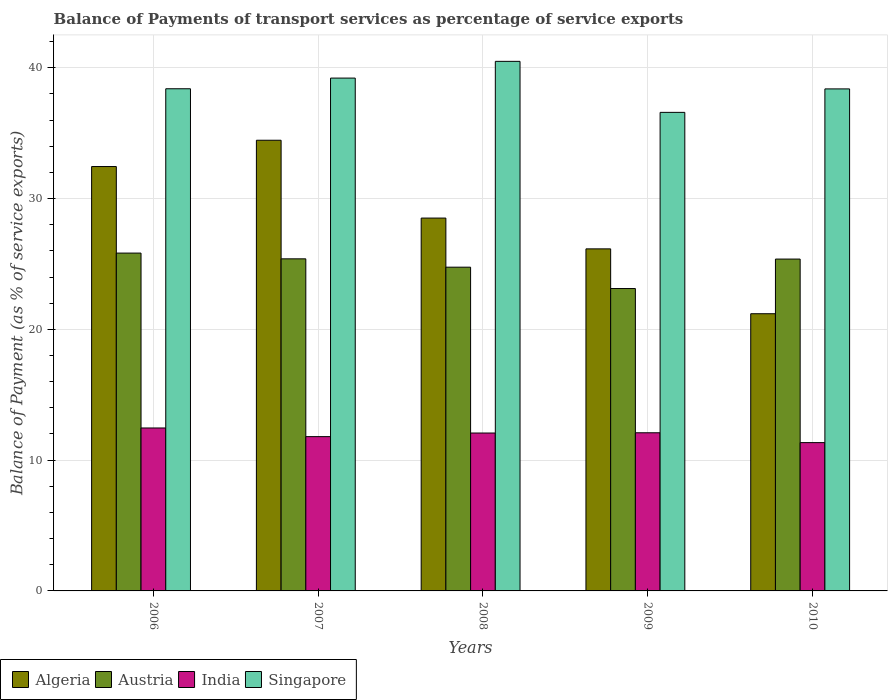How many different coloured bars are there?
Keep it short and to the point. 4. Are the number of bars per tick equal to the number of legend labels?
Your response must be concise. Yes. Are the number of bars on each tick of the X-axis equal?
Your answer should be very brief. Yes. How many bars are there on the 1st tick from the left?
Give a very brief answer. 4. How many bars are there on the 3rd tick from the right?
Give a very brief answer. 4. What is the label of the 1st group of bars from the left?
Keep it short and to the point. 2006. In how many cases, is the number of bars for a given year not equal to the number of legend labels?
Keep it short and to the point. 0. What is the balance of payments of transport services in Singapore in 2007?
Keep it short and to the point. 39.21. Across all years, what is the maximum balance of payments of transport services in Singapore?
Provide a short and direct response. 40.49. Across all years, what is the minimum balance of payments of transport services in Singapore?
Offer a very short reply. 36.59. In which year was the balance of payments of transport services in Singapore minimum?
Your answer should be compact. 2009. What is the total balance of payments of transport services in Austria in the graph?
Offer a very short reply. 124.48. What is the difference between the balance of payments of transport services in Algeria in 2009 and that in 2010?
Give a very brief answer. 4.96. What is the difference between the balance of payments of transport services in Austria in 2007 and the balance of payments of transport services in Algeria in 2006?
Offer a very short reply. -7.06. What is the average balance of payments of transport services in Singapore per year?
Provide a short and direct response. 38.62. In the year 2010, what is the difference between the balance of payments of transport services in Singapore and balance of payments of transport services in India?
Offer a terse response. 27.05. What is the ratio of the balance of payments of transport services in Algeria in 2006 to that in 2008?
Your response must be concise. 1.14. Is the balance of payments of transport services in India in 2006 less than that in 2008?
Ensure brevity in your answer.  No. What is the difference between the highest and the second highest balance of payments of transport services in Austria?
Your response must be concise. 0.44. What is the difference between the highest and the lowest balance of payments of transport services in India?
Keep it short and to the point. 1.12. Is it the case that in every year, the sum of the balance of payments of transport services in Austria and balance of payments of transport services in Singapore is greater than the balance of payments of transport services in India?
Offer a very short reply. Yes. How many bars are there?
Make the answer very short. 20. How many years are there in the graph?
Keep it short and to the point. 5. Are the values on the major ticks of Y-axis written in scientific E-notation?
Make the answer very short. No. Where does the legend appear in the graph?
Your answer should be very brief. Bottom left. How many legend labels are there?
Ensure brevity in your answer.  4. How are the legend labels stacked?
Keep it short and to the point. Horizontal. What is the title of the graph?
Provide a succinct answer. Balance of Payments of transport services as percentage of service exports. Does "Tuvalu" appear as one of the legend labels in the graph?
Provide a succinct answer. No. What is the label or title of the Y-axis?
Your answer should be compact. Balance of Payment (as % of service exports). What is the Balance of Payment (as % of service exports) in Algeria in 2006?
Your response must be concise. 32.45. What is the Balance of Payment (as % of service exports) of Austria in 2006?
Ensure brevity in your answer.  25.83. What is the Balance of Payment (as % of service exports) of India in 2006?
Your answer should be very brief. 12.46. What is the Balance of Payment (as % of service exports) in Singapore in 2006?
Ensure brevity in your answer.  38.4. What is the Balance of Payment (as % of service exports) in Algeria in 2007?
Your response must be concise. 34.46. What is the Balance of Payment (as % of service exports) of Austria in 2007?
Provide a succinct answer. 25.39. What is the Balance of Payment (as % of service exports) of India in 2007?
Your response must be concise. 11.8. What is the Balance of Payment (as % of service exports) in Singapore in 2007?
Provide a short and direct response. 39.21. What is the Balance of Payment (as % of service exports) of Algeria in 2008?
Your response must be concise. 28.51. What is the Balance of Payment (as % of service exports) of Austria in 2008?
Your answer should be very brief. 24.75. What is the Balance of Payment (as % of service exports) in India in 2008?
Your response must be concise. 12.07. What is the Balance of Payment (as % of service exports) in Singapore in 2008?
Offer a very short reply. 40.49. What is the Balance of Payment (as % of service exports) in Algeria in 2009?
Keep it short and to the point. 26.15. What is the Balance of Payment (as % of service exports) of Austria in 2009?
Keep it short and to the point. 23.12. What is the Balance of Payment (as % of service exports) in India in 2009?
Keep it short and to the point. 12.09. What is the Balance of Payment (as % of service exports) of Singapore in 2009?
Make the answer very short. 36.59. What is the Balance of Payment (as % of service exports) of Algeria in 2010?
Provide a short and direct response. 21.2. What is the Balance of Payment (as % of service exports) in Austria in 2010?
Make the answer very short. 25.37. What is the Balance of Payment (as % of service exports) in India in 2010?
Give a very brief answer. 11.34. What is the Balance of Payment (as % of service exports) of Singapore in 2010?
Provide a succinct answer. 38.39. Across all years, what is the maximum Balance of Payment (as % of service exports) of Algeria?
Your response must be concise. 34.46. Across all years, what is the maximum Balance of Payment (as % of service exports) of Austria?
Provide a succinct answer. 25.83. Across all years, what is the maximum Balance of Payment (as % of service exports) of India?
Provide a short and direct response. 12.46. Across all years, what is the maximum Balance of Payment (as % of service exports) of Singapore?
Keep it short and to the point. 40.49. Across all years, what is the minimum Balance of Payment (as % of service exports) in Algeria?
Offer a very short reply. 21.2. Across all years, what is the minimum Balance of Payment (as % of service exports) of Austria?
Provide a succinct answer. 23.12. Across all years, what is the minimum Balance of Payment (as % of service exports) of India?
Make the answer very short. 11.34. Across all years, what is the minimum Balance of Payment (as % of service exports) of Singapore?
Provide a succinct answer. 36.59. What is the total Balance of Payment (as % of service exports) of Algeria in the graph?
Your response must be concise. 142.77. What is the total Balance of Payment (as % of service exports) in Austria in the graph?
Offer a terse response. 124.48. What is the total Balance of Payment (as % of service exports) in India in the graph?
Your answer should be very brief. 59.76. What is the total Balance of Payment (as % of service exports) of Singapore in the graph?
Keep it short and to the point. 193.08. What is the difference between the Balance of Payment (as % of service exports) of Algeria in 2006 and that in 2007?
Give a very brief answer. -2.01. What is the difference between the Balance of Payment (as % of service exports) in Austria in 2006 and that in 2007?
Make the answer very short. 0.44. What is the difference between the Balance of Payment (as % of service exports) in India in 2006 and that in 2007?
Provide a succinct answer. 0.66. What is the difference between the Balance of Payment (as % of service exports) in Singapore in 2006 and that in 2007?
Provide a succinct answer. -0.82. What is the difference between the Balance of Payment (as % of service exports) in Algeria in 2006 and that in 2008?
Make the answer very short. 3.94. What is the difference between the Balance of Payment (as % of service exports) in Austria in 2006 and that in 2008?
Offer a very short reply. 1.08. What is the difference between the Balance of Payment (as % of service exports) in India in 2006 and that in 2008?
Offer a very short reply. 0.39. What is the difference between the Balance of Payment (as % of service exports) of Singapore in 2006 and that in 2008?
Offer a terse response. -2.1. What is the difference between the Balance of Payment (as % of service exports) in Algeria in 2006 and that in 2009?
Your response must be concise. 6.29. What is the difference between the Balance of Payment (as % of service exports) in Austria in 2006 and that in 2009?
Provide a short and direct response. 2.71. What is the difference between the Balance of Payment (as % of service exports) in India in 2006 and that in 2009?
Your response must be concise. 0.37. What is the difference between the Balance of Payment (as % of service exports) of Singapore in 2006 and that in 2009?
Your answer should be very brief. 1.81. What is the difference between the Balance of Payment (as % of service exports) of Algeria in 2006 and that in 2010?
Provide a succinct answer. 11.25. What is the difference between the Balance of Payment (as % of service exports) in Austria in 2006 and that in 2010?
Your answer should be compact. 0.46. What is the difference between the Balance of Payment (as % of service exports) in India in 2006 and that in 2010?
Make the answer very short. 1.12. What is the difference between the Balance of Payment (as % of service exports) in Singapore in 2006 and that in 2010?
Make the answer very short. 0.01. What is the difference between the Balance of Payment (as % of service exports) of Algeria in 2007 and that in 2008?
Offer a terse response. 5.95. What is the difference between the Balance of Payment (as % of service exports) in Austria in 2007 and that in 2008?
Give a very brief answer. 0.64. What is the difference between the Balance of Payment (as % of service exports) in India in 2007 and that in 2008?
Make the answer very short. -0.28. What is the difference between the Balance of Payment (as % of service exports) of Singapore in 2007 and that in 2008?
Give a very brief answer. -1.28. What is the difference between the Balance of Payment (as % of service exports) of Algeria in 2007 and that in 2009?
Provide a short and direct response. 8.31. What is the difference between the Balance of Payment (as % of service exports) of Austria in 2007 and that in 2009?
Your answer should be compact. 2.27. What is the difference between the Balance of Payment (as % of service exports) of India in 2007 and that in 2009?
Give a very brief answer. -0.3. What is the difference between the Balance of Payment (as % of service exports) of Singapore in 2007 and that in 2009?
Your response must be concise. 2.62. What is the difference between the Balance of Payment (as % of service exports) in Algeria in 2007 and that in 2010?
Keep it short and to the point. 13.27. What is the difference between the Balance of Payment (as % of service exports) in Austria in 2007 and that in 2010?
Keep it short and to the point. 0.02. What is the difference between the Balance of Payment (as % of service exports) of India in 2007 and that in 2010?
Your answer should be compact. 0.46. What is the difference between the Balance of Payment (as % of service exports) in Singapore in 2007 and that in 2010?
Your answer should be compact. 0.83. What is the difference between the Balance of Payment (as % of service exports) of Algeria in 2008 and that in 2009?
Offer a very short reply. 2.35. What is the difference between the Balance of Payment (as % of service exports) in Austria in 2008 and that in 2009?
Your answer should be very brief. 1.63. What is the difference between the Balance of Payment (as % of service exports) of India in 2008 and that in 2009?
Provide a short and direct response. -0.02. What is the difference between the Balance of Payment (as % of service exports) in Singapore in 2008 and that in 2009?
Make the answer very short. 3.9. What is the difference between the Balance of Payment (as % of service exports) of Algeria in 2008 and that in 2010?
Provide a short and direct response. 7.31. What is the difference between the Balance of Payment (as % of service exports) of Austria in 2008 and that in 2010?
Give a very brief answer. -0.62. What is the difference between the Balance of Payment (as % of service exports) in India in 2008 and that in 2010?
Your response must be concise. 0.73. What is the difference between the Balance of Payment (as % of service exports) in Singapore in 2008 and that in 2010?
Ensure brevity in your answer.  2.11. What is the difference between the Balance of Payment (as % of service exports) of Algeria in 2009 and that in 2010?
Make the answer very short. 4.96. What is the difference between the Balance of Payment (as % of service exports) in Austria in 2009 and that in 2010?
Your answer should be compact. -2.25. What is the difference between the Balance of Payment (as % of service exports) in India in 2009 and that in 2010?
Keep it short and to the point. 0.75. What is the difference between the Balance of Payment (as % of service exports) in Singapore in 2009 and that in 2010?
Provide a short and direct response. -1.79. What is the difference between the Balance of Payment (as % of service exports) of Algeria in 2006 and the Balance of Payment (as % of service exports) of Austria in 2007?
Ensure brevity in your answer.  7.06. What is the difference between the Balance of Payment (as % of service exports) in Algeria in 2006 and the Balance of Payment (as % of service exports) in India in 2007?
Keep it short and to the point. 20.65. What is the difference between the Balance of Payment (as % of service exports) in Algeria in 2006 and the Balance of Payment (as % of service exports) in Singapore in 2007?
Provide a succinct answer. -6.76. What is the difference between the Balance of Payment (as % of service exports) of Austria in 2006 and the Balance of Payment (as % of service exports) of India in 2007?
Make the answer very short. 14.03. What is the difference between the Balance of Payment (as % of service exports) in Austria in 2006 and the Balance of Payment (as % of service exports) in Singapore in 2007?
Give a very brief answer. -13.38. What is the difference between the Balance of Payment (as % of service exports) in India in 2006 and the Balance of Payment (as % of service exports) in Singapore in 2007?
Keep it short and to the point. -26.75. What is the difference between the Balance of Payment (as % of service exports) in Algeria in 2006 and the Balance of Payment (as % of service exports) in Austria in 2008?
Your answer should be compact. 7.69. What is the difference between the Balance of Payment (as % of service exports) in Algeria in 2006 and the Balance of Payment (as % of service exports) in India in 2008?
Your response must be concise. 20.38. What is the difference between the Balance of Payment (as % of service exports) in Algeria in 2006 and the Balance of Payment (as % of service exports) in Singapore in 2008?
Provide a short and direct response. -8.04. What is the difference between the Balance of Payment (as % of service exports) in Austria in 2006 and the Balance of Payment (as % of service exports) in India in 2008?
Provide a short and direct response. 13.76. What is the difference between the Balance of Payment (as % of service exports) in Austria in 2006 and the Balance of Payment (as % of service exports) in Singapore in 2008?
Your answer should be very brief. -14.66. What is the difference between the Balance of Payment (as % of service exports) of India in 2006 and the Balance of Payment (as % of service exports) of Singapore in 2008?
Give a very brief answer. -28.03. What is the difference between the Balance of Payment (as % of service exports) in Algeria in 2006 and the Balance of Payment (as % of service exports) in Austria in 2009?
Offer a terse response. 9.33. What is the difference between the Balance of Payment (as % of service exports) of Algeria in 2006 and the Balance of Payment (as % of service exports) of India in 2009?
Provide a short and direct response. 20.36. What is the difference between the Balance of Payment (as % of service exports) in Algeria in 2006 and the Balance of Payment (as % of service exports) in Singapore in 2009?
Your answer should be compact. -4.14. What is the difference between the Balance of Payment (as % of service exports) in Austria in 2006 and the Balance of Payment (as % of service exports) in India in 2009?
Offer a very short reply. 13.74. What is the difference between the Balance of Payment (as % of service exports) in Austria in 2006 and the Balance of Payment (as % of service exports) in Singapore in 2009?
Your answer should be very brief. -10.76. What is the difference between the Balance of Payment (as % of service exports) in India in 2006 and the Balance of Payment (as % of service exports) in Singapore in 2009?
Ensure brevity in your answer.  -24.13. What is the difference between the Balance of Payment (as % of service exports) in Algeria in 2006 and the Balance of Payment (as % of service exports) in Austria in 2010?
Ensure brevity in your answer.  7.07. What is the difference between the Balance of Payment (as % of service exports) in Algeria in 2006 and the Balance of Payment (as % of service exports) in India in 2010?
Make the answer very short. 21.11. What is the difference between the Balance of Payment (as % of service exports) of Algeria in 2006 and the Balance of Payment (as % of service exports) of Singapore in 2010?
Give a very brief answer. -5.94. What is the difference between the Balance of Payment (as % of service exports) of Austria in 2006 and the Balance of Payment (as % of service exports) of India in 2010?
Your answer should be compact. 14.49. What is the difference between the Balance of Payment (as % of service exports) of Austria in 2006 and the Balance of Payment (as % of service exports) of Singapore in 2010?
Your answer should be compact. -12.55. What is the difference between the Balance of Payment (as % of service exports) of India in 2006 and the Balance of Payment (as % of service exports) of Singapore in 2010?
Provide a succinct answer. -25.93. What is the difference between the Balance of Payment (as % of service exports) of Algeria in 2007 and the Balance of Payment (as % of service exports) of Austria in 2008?
Make the answer very short. 9.71. What is the difference between the Balance of Payment (as % of service exports) of Algeria in 2007 and the Balance of Payment (as % of service exports) of India in 2008?
Offer a terse response. 22.39. What is the difference between the Balance of Payment (as % of service exports) in Algeria in 2007 and the Balance of Payment (as % of service exports) in Singapore in 2008?
Keep it short and to the point. -6.03. What is the difference between the Balance of Payment (as % of service exports) of Austria in 2007 and the Balance of Payment (as % of service exports) of India in 2008?
Offer a terse response. 13.32. What is the difference between the Balance of Payment (as % of service exports) of Austria in 2007 and the Balance of Payment (as % of service exports) of Singapore in 2008?
Give a very brief answer. -15.1. What is the difference between the Balance of Payment (as % of service exports) in India in 2007 and the Balance of Payment (as % of service exports) in Singapore in 2008?
Your response must be concise. -28.7. What is the difference between the Balance of Payment (as % of service exports) of Algeria in 2007 and the Balance of Payment (as % of service exports) of Austria in 2009?
Make the answer very short. 11.34. What is the difference between the Balance of Payment (as % of service exports) of Algeria in 2007 and the Balance of Payment (as % of service exports) of India in 2009?
Make the answer very short. 22.37. What is the difference between the Balance of Payment (as % of service exports) in Algeria in 2007 and the Balance of Payment (as % of service exports) in Singapore in 2009?
Provide a short and direct response. -2.13. What is the difference between the Balance of Payment (as % of service exports) of Austria in 2007 and the Balance of Payment (as % of service exports) of India in 2009?
Give a very brief answer. 13.3. What is the difference between the Balance of Payment (as % of service exports) of Austria in 2007 and the Balance of Payment (as % of service exports) of Singapore in 2009?
Offer a terse response. -11.2. What is the difference between the Balance of Payment (as % of service exports) in India in 2007 and the Balance of Payment (as % of service exports) in Singapore in 2009?
Provide a succinct answer. -24.79. What is the difference between the Balance of Payment (as % of service exports) in Algeria in 2007 and the Balance of Payment (as % of service exports) in Austria in 2010?
Offer a terse response. 9.09. What is the difference between the Balance of Payment (as % of service exports) in Algeria in 2007 and the Balance of Payment (as % of service exports) in India in 2010?
Ensure brevity in your answer.  23.12. What is the difference between the Balance of Payment (as % of service exports) in Algeria in 2007 and the Balance of Payment (as % of service exports) in Singapore in 2010?
Provide a short and direct response. -3.93. What is the difference between the Balance of Payment (as % of service exports) in Austria in 2007 and the Balance of Payment (as % of service exports) in India in 2010?
Your answer should be compact. 14.05. What is the difference between the Balance of Payment (as % of service exports) in Austria in 2007 and the Balance of Payment (as % of service exports) in Singapore in 2010?
Your answer should be very brief. -12.99. What is the difference between the Balance of Payment (as % of service exports) in India in 2007 and the Balance of Payment (as % of service exports) in Singapore in 2010?
Keep it short and to the point. -26.59. What is the difference between the Balance of Payment (as % of service exports) of Algeria in 2008 and the Balance of Payment (as % of service exports) of Austria in 2009?
Make the answer very short. 5.39. What is the difference between the Balance of Payment (as % of service exports) in Algeria in 2008 and the Balance of Payment (as % of service exports) in India in 2009?
Make the answer very short. 16.42. What is the difference between the Balance of Payment (as % of service exports) in Algeria in 2008 and the Balance of Payment (as % of service exports) in Singapore in 2009?
Provide a succinct answer. -8.08. What is the difference between the Balance of Payment (as % of service exports) in Austria in 2008 and the Balance of Payment (as % of service exports) in India in 2009?
Offer a terse response. 12.66. What is the difference between the Balance of Payment (as % of service exports) of Austria in 2008 and the Balance of Payment (as % of service exports) of Singapore in 2009?
Make the answer very short. -11.84. What is the difference between the Balance of Payment (as % of service exports) in India in 2008 and the Balance of Payment (as % of service exports) in Singapore in 2009?
Your answer should be very brief. -24.52. What is the difference between the Balance of Payment (as % of service exports) in Algeria in 2008 and the Balance of Payment (as % of service exports) in Austria in 2010?
Your answer should be very brief. 3.13. What is the difference between the Balance of Payment (as % of service exports) of Algeria in 2008 and the Balance of Payment (as % of service exports) of India in 2010?
Provide a short and direct response. 17.17. What is the difference between the Balance of Payment (as % of service exports) in Algeria in 2008 and the Balance of Payment (as % of service exports) in Singapore in 2010?
Provide a short and direct response. -9.88. What is the difference between the Balance of Payment (as % of service exports) in Austria in 2008 and the Balance of Payment (as % of service exports) in India in 2010?
Make the answer very short. 13.41. What is the difference between the Balance of Payment (as % of service exports) of Austria in 2008 and the Balance of Payment (as % of service exports) of Singapore in 2010?
Keep it short and to the point. -13.63. What is the difference between the Balance of Payment (as % of service exports) in India in 2008 and the Balance of Payment (as % of service exports) in Singapore in 2010?
Your response must be concise. -26.31. What is the difference between the Balance of Payment (as % of service exports) in Algeria in 2009 and the Balance of Payment (as % of service exports) in Austria in 2010?
Offer a very short reply. 0.78. What is the difference between the Balance of Payment (as % of service exports) of Algeria in 2009 and the Balance of Payment (as % of service exports) of India in 2010?
Offer a very short reply. 14.81. What is the difference between the Balance of Payment (as % of service exports) of Algeria in 2009 and the Balance of Payment (as % of service exports) of Singapore in 2010?
Ensure brevity in your answer.  -12.23. What is the difference between the Balance of Payment (as % of service exports) in Austria in 2009 and the Balance of Payment (as % of service exports) in India in 2010?
Keep it short and to the point. 11.78. What is the difference between the Balance of Payment (as % of service exports) of Austria in 2009 and the Balance of Payment (as % of service exports) of Singapore in 2010?
Give a very brief answer. -15.26. What is the difference between the Balance of Payment (as % of service exports) in India in 2009 and the Balance of Payment (as % of service exports) in Singapore in 2010?
Provide a succinct answer. -26.29. What is the average Balance of Payment (as % of service exports) in Algeria per year?
Your response must be concise. 28.55. What is the average Balance of Payment (as % of service exports) in Austria per year?
Give a very brief answer. 24.89. What is the average Balance of Payment (as % of service exports) in India per year?
Offer a very short reply. 11.95. What is the average Balance of Payment (as % of service exports) in Singapore per year?
Keep it short and to the point. 38.62. In the year 2006, what is the difference between the Balance of Payment (as % of service exports) in Algeria and Balance of Payment (as % of service exports) in Austria?
Your answer should be compact. 6.62. In the year 2006, what is the difference between the Balance of Payment (as % of service exports) of Algeria and Balance of Payment (as % of service exports) of India?
Your answer should be compact. 19.99. In the year 2006, what is the difference between the Balance of Payment (as % of service exports) in Algeria and Balance of Payment (as % of service exports) in Singapore?
Your answer should be compact. -5.95. In the year 2006, what is the difference between the Balance of Payment (as % of service exports) in Austria and Balance of Payment (as % of service exports) in India?
Your answer should be very brief. 13.37. In the year 2006, what is the difference between the Balance of Payment (as % of service exports) of Austria and Balance of Payment (as % of service exports) of Singapore?
Give a very brief answer. -12.57. In the year 2006, what is the difference between the Balance of Payment (as % of service exports) of India and Balance of Payment (as % of service exports) of Singapore?
Your answer should be compact. -25.94. In the year 2007, what is the difference between the Balance of Payment (as % of service exports) in Algeria and Balance of Payment (as % of service exports) in Austria?
Give a very brief answer. 9.07. In the year 2007, what is the difference between the Balance of Payment (as % of service exports) in Algeria and Balance of Payment (as % of service exports) in India?
Keep it short and to the point. 22.66. In the year 2007, what is the difference between the Balance of Payment (as % of service exports) of Algeria and Balance of Payment (as % of service exports) of Singapore?
Make the answer very short. -4.75. In the year 2007, what is the difference between the Balance of Payment (as % of service exports) in Austria and Balance of Payment (as % of service exports) in India?
Offer a very short reply. 13.6. In the year 2007, what is the difference between the Balance of Payment (as % of service exports) in Austria and Balance of Payment (as % of service exports) in Singapore?
Your answer should be very brief. -13.82. In the year 2007, what is the difference between the Balance of Payment (as % of service exports) in India and Balance of Payment (as % of service exports) in Singapore?
Your response must be concise. -27.42. In the year 2008, what is the difference between the Balance of Payment (as % of service exports) of Algeria and Balance of Payment (as % of service exports) of Austria?
Ensure brevity in your answer.  3.75. In the year 2008, what is the difference between the Balance of Payment (as % of service exports) of Algeria and Balance of Payment (as % of service exports) of India?
Your answer should be very brief. 16.44. In the year 2008, what is the difference between the Balance of Payment (as % of service exports) of Algeria and Balance of Payment (as % of service exports) of Singapore?
Offer a terse response. -11.98. In the year 2008, what is the difference between the Balance of Payment (as % of service exports) of Austria and Balance of Payment (as % of service exports) of India?
Offer a terse response. 12.68. In the year 2008, what is the difference between the Balance of Payment (as % of service exports) in Austria and Balance of Payment (as % of service exports) in Singapore?
Provide a short and direct response. -15.74. In the year 2008, what is the difference between the Balance of Payment (as % of service exports) of India and Balance of Payment (as % of service exports) of Singapore?
Keep it short and to the point. -28.42. In the year 2009, what is the difference between the Balance of Payment (as % of service exports) in Algeria and Balance of Payment (as % of service exports) in Austria?
Give a very brief answer. 3.03. In the year 2009, what is the difference between the Balance of Payment (as % of service exports) of Algeria and Balance of Payment (as % of service exports) of India?
Your response must be concise. 14.06. In the year 2009, what is the difference between the Balance of Payment (as % of service exports) of Algeria and Balance of Payment (as % of service exports) of Singapore?
Give a very brief answer. -10.44. In the year 2009, what is the difference between the Balance of Payment (as % of service exports) in Austria and Balance of Payment (as % of service exports) in India?
Ensure brevity in your answer.  11.03. In the year 2009, what is the difference between the Balance of Payment (as % of service exports) in Austria and Balance of Payment (as % of service exports) in Singapore?
Your answer should be very brief. -13.47. In the year 2009, what is the difference between the Balance of Payment (as % of service exports) of India and Balance of Payment (as % of service exports) of Singapore?
Provide a short and direct response. -24.5. In the year 2010, what is the difference between the Balance of Payment (as % of service exports) in Algeria and Balance of Payment (as % of service exports) in Austria?
Your response must be concise. -4.18. In the year 2010, what is the difference between the Balance of Payment (as % of service exports) in Algeria and Balance of Payment (as % of service exports) in India?
Offer a very short reply. 9.86. In the year 2010, what is the difference between the Balance of Payment (as % of service exports) of Algeria and Balance of Payment (as % of service exports) of Singapore?
Provide a short and direct response. -17.19. In the year 2010, what is the difference between the Balance of Payment (as % of service exports) of Austria and Balance of Payment (as % of service exports) of India?
Provide a succinct answer. 14.04. In the year 2010, what is the difference between the Balance of Payment (as % of service exports) of Austria and Balance of Payment (as % of service exports) of Singapore?
Offer a very short reply. -13.01. In the year 2010, what is the difference between the Balance of Payment (as % of service exports) of India and Balance of Payment (as % of service exports) of Singapore?
Your response must be concise. -27.05. What is the ratio of the Balance of Payment (as % of service exports) of Algeria in 2006 to that in 2007?
Provide a short and direct response. 0.94. What is the ratio of the Balance of Payment (as % of service exports) in Austria in 2006 to that in 2007?
Provide a short and direct response. 1.02. What is the ratio of the Balance of Payment (as % of service exports) of India in 2006 to that in 2007?
Your answer should be compact. 1.06. What is the ratio of the Balance of Payment (as % of service exports) of Singapore in 2006 to that in 2007?
Offer a terse response. 0.98. What is the ratio of the Balance of Payment (as % of service exports) of Algeria in 2006 to that in 2008?
Your response must be concise. 1.14. What is the ratio of the Balance of Payment (as % of service exports) of Austria in 2006 to that in 2008?
Your response must be concise. 1.04. What is the ratio of the Balance of Payment (as % of service exports) of India in 2006 to that in 2008?
Ensure brevity in your answer.  1.03. What is the ratio of the Balance of Payment (as % of service exports) in Singapore in 2006 to that in 2008?
Keep it short and to the point. 0.95. What is the ratio of the Balance of Payment (as % of service exports) of Algeria in 2006 to that in 2009?
Provide a short and direct response. 1.24. What is the ratio of the Balance of Payment (as % of service exports) in Austria in 2006 to that in 2009?
Keep it short and to the point. 1.12. What is the ratio of the Balance of Payment (as % of service exports) of India in 2006 to that in 2009?
Offer a very short reply. 1.03. What is the ratio of the Balance of Payment (as % of service exports) of Singapore in 2006 to that in 2009?
Keep it short and to the point. 1.05. What is the ratio of the Balance of Payment (as % of service exports) of Algeria in 2006 to that in 2010?
Ensure brevity in your answer.  1.53. What is the ratio of the Balance of Payment (as % of service exports) of India in 2006 to that in 2010?
Ensure brevity in your answer.  1.1. What is the ratio of the Balance of Payment (as % of service exports) of Singapore in 2006 to that in 2010?
Ensure brevity in your answer.  1. What is the ratio of the Balance of Payment (as % of service exports) in Algeria in 2007 to that in 2008?
Give a very brief answer. 1.21. What is the ratio of the Balance of Payment (as % of service exports) in Austria in 2007 to that in 2008?
Give a very brief answer. 1.03. What is the ratio of the Balance of Payment (as % of service exports) of India in 2007 to that in 2008?
Ensure brevity in your answer.  0.98. What is the ratio of the Balance of Payment (as % of service exports) of Singapore in 2007 to that in 2008?
Provide a short and direct response. 0.97. What is the ratio of the Balance of Payment (as % of service exports) of Algeria in 2007 to that in 2009?
Provide a short and direct response. 1.32. What is the ratio of the Balance of Payment (as % of service exports) in Austria in 2007 to that in 2009?
Ensure brevity in your answer.  1.1. What is the ratio of the Balance of Payment (as % of service exports) in India in 2007 to that in 2009?
Your answer should be compact. 0.98. What is the ratio of the Balance of Payment (as % of service exports) in Singapore in 2007 to that in 2009?
Your answer should be very brief. 1.07. What is the ratio of the Balance of Payment (as % of service exports) of Algeria in 2007 to that in 2010?
Your response must be concise. 1.63. What is the ratio of the Balance of Payment (as % of service exports) of India in 2007 to that in 2010?
Your response must be concise. 1.04. What is the ratio of the Balance of Payment (as % of service exports) of Singapore in 2007 to that in 2010?
Provide a short and direct response. 1.02. What is the ratio of the Balance of Payment (as % of service exports) in Algeria in 2008 to that in 2009?
Ensure brevity in your answer.  1.09. What is the ratio of the Balance of Payment (as % of service exports) of Austria in 2008 to that in 2009?
Your answer should be compact. 1.07. What is the ratio of the Balance of Payment (as % of service exports) in Singapore in 2008 to that in 2009?
Provide a short and direct response. 1.11. What is the ratio of the Balance of Payment (as % of service exports) in Algeria in 2008 to that in 2010?
Provide a short and direct response. 1.35. What is the ratio of the Balance of Payment (as % of service exports) of Austria in 2008 to that in 2010?
Offer a terse response. 0.98. What is the ratio of the Balance of Payment (as % of service exports) in India in 2008 to that in 2010?
Provide a short and direct response. 1.06. What is the ratio of the Balance of Payment (as % of service exports) in Singapore in 2008 to that in 2010?
Your answer should be very brief. 1.05. What is the ratio of the Balance of Payment (as % of service exports) in Algeria in 2009 to that in 2010?
Offer a very short reply. 1.23. What is the ratio of the Balance of Payment (as % of service exports) of Austria in 2009 to that in 2010?
Give a very brief answer. 0.91. What is the ratio of the Balance of Payment (as % of service exports) in India in 2009 to that in 2010?
Your answer should be very brief. 1.07. What is the ratio of the Balance of Payment (as % of service exports) of Singapore in 2009 to that in 2010?
Provide a succinct answer. 0.95. What is the difference between the highest and the second highest Balance of Payment (as % of service exports) in Algeria?
Ensure brevity in your answer.  2.01. What is the difference between the highest and the second highest Balance of Payment (as % of service exports) of Austria?
Ensure brevity in your answer.  0.44. What is the difference between the highest and the second highest Balance of Payment (as % of service exports) of India?
Your response must be concise. 0.37. What is the difference between the highest and the second highest Balance of Payment (as % of service exports) in Singapore?
Provide a succinct answer. 1.28. What is the difference between the highest and the lowest Balance of Payment (as % of service exports) in Algeria?
Ensure brevity in your answer.  13.27. What is the difference between the highest and the lowest Balance of Payment (as % of service exports) in Austria?
Make the answer very short. 2.71. What is the difference between the highest and the lowest Balance of Payment (as % of service exports) of India?
Keep it short and to the point. 1.12. What is the difference between the highest and the lowest Balance of Payment (as % of service exports) in Singapore?
Give a very brief answer. 3.9. 